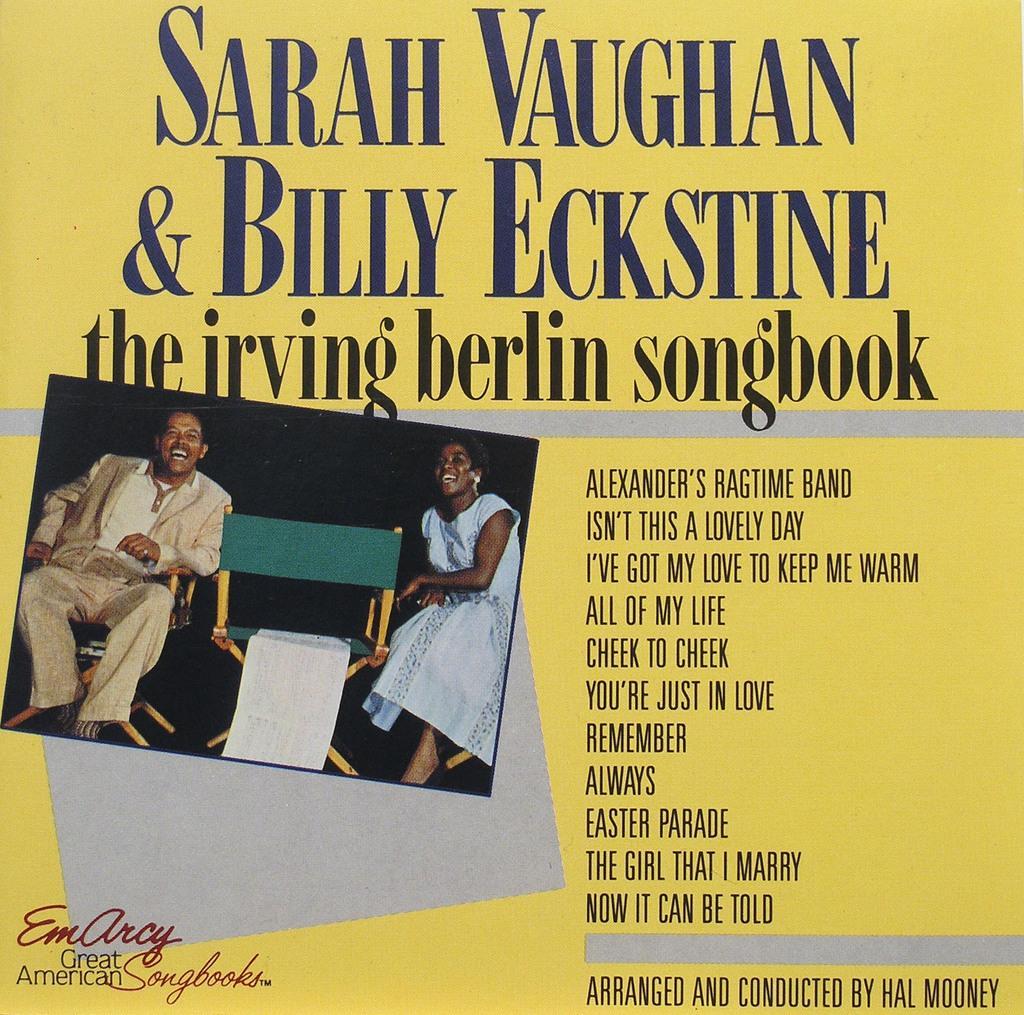Please provide a concise description of this image. In this picture there is an image of two persons sitting in chairs and there is something written above and beside the image. 